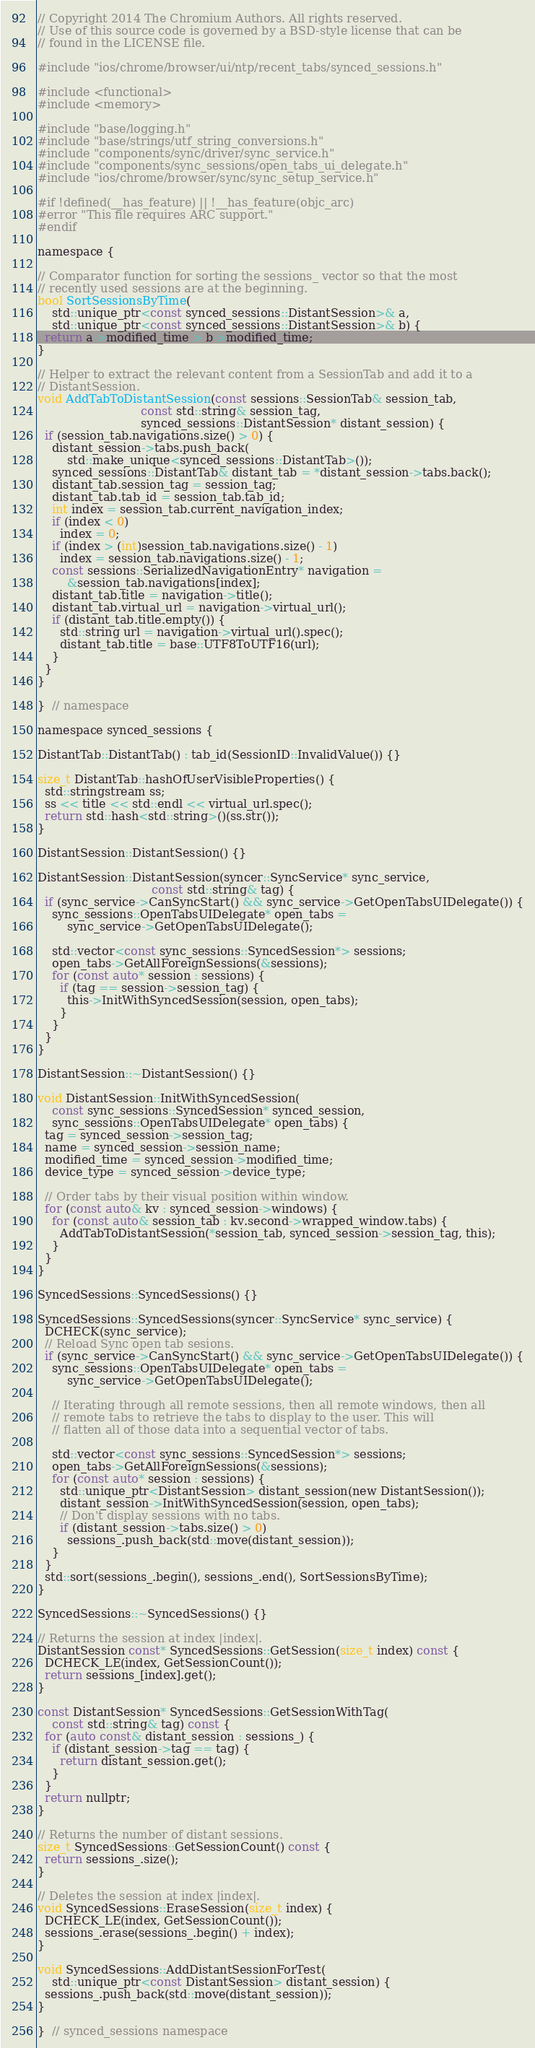<code> <loc_0><loc_0><loc_500><loc_500><_ObjectiveC_>// Copyright 2014 The Chromium Authors. All rights reserved.
// Use of this source code is governed by a BSD-style license that can be
// found in the LICENSE file.

#include "ios/chrome/browser/ui/ntp/recent_tabs/synced_sessions.h"

#include <functional>
#include <memory>

#include "base/logging.h"
#include "base/strings/utf_string_conversions.h"
#include "components/sync/driver/sync_service.h"
#include "components/sync_sessions/open_tabs_ui_delegate.h"
#include "ios/chrome/browser/sync/sync_setup_service.h"

#if !defined(__has_feature) || !__has_feature(objc_arc)
#error "This file requires ARC support."
#endif

namespace {

// Comparator function for sorting the sessions_ vector so that the most
// recently used sessions are at the beginning.
bool SortSessionsByTime(
    std::unique_ptr<const synced_sessions::DistantSession>& a,
    std::unique_ptr<const synced_sessions::DistantSession>& b) {
  return a->modified_time > b->modified_time;
}

// Helper to extract the relevant content from a SessionTab and add it to a
// DistantSession.
void AddTabToDistantSession(const sessions::SessionTab& session_tab,
                            const std::string& session_tag,
                            synced_sessions::DistantSession* distant_session) {
  if (session_tab.navigations.size() > 0) {
    distant_session->tabs.push_back(
        std::make_unique<synced_sessions::DistantTab>());
    synced_sessions::DistantTab& distant_tab = *distant_session->tabs.back();
    distant_tab.session_tag = session_tag;
    distant_tab.tab_id = session_tab.tab_id;
    int index = session_tab.current_navigation_index;
    if (index < 0)
      index = 0;
    if (index > (int)session_tab.navigations.size() - 1)
      index = session_tab.navigations.size() - 1;
    const sessions::SerializedNavigationEntry* navigation =
        &session_tab.navigations[index];
    distant_tab.title = navigation->title();
    distant_tab.virtual_url = navigation->virtual_url();
    if (distant_tab.title.empty()) {
      std::string url = navigation->virtual_url().spec();
      distant_tab.title = base::UTF8ToUTF16(url);
    }
  }
}

}  // namespace

namespace synced_sessions {

DistantTab::DistantTab() : tab_id(SessionID::InvalidValue()) {}

size_t DistantTab::hashOfUserVisibleProperties() {
  std::stringstream ss;
  ss << title << std::endl << virtual_url.spec();
  return std::hash<std::string>()(ss.str());
}

DistantSession::DistantSession() {}

DistantSession::DistantSession(syncer::SyncService* sync_service,
                               const std::string& tag) {
  if (sync_service->CanSyncStart() && sync_service->GetOpenTabsUIDelegate()) {
    sync_sessions::OpenTabsUIDelegate* open_tabs =
        sync_service->GetOpenTabsUIDelegate();

    std::vector<const sync_sessions::SyncedSession*> sessions;
    open_tabs->GetAllForeignSessions(&sessions);
    for (const auto* session : sessions) {
      if (tag == session->session_tag) {
        this->InitWithSyncedSession(session, open_tabs);
      }
    }
  }
}

DistantSession::~DistantSession() {}

void DistantSession::InitWithSyncedSession(
    const sync_sessions::SyncedSession* synced_session,
    sync_sessions::OpenTabsUIDelegate* open_tabs) {
  tag = synced_session->session_tag;
  name = synced_session->session_name;
  modified_time = synced_session->modified_time;
  device_type = synced_session->device_type;

  // Order tabs by their visual position within window.
  for (const auto& kv : synced_session->windows) {
    for (const auto& session_tab : kv.second->wrapped_window.tabs) {
      AddTabToDistantSession(*session_tab, synced_session->session_tag, this);
    }
  }
}

SyncedSessions::SyncedSessions() {}

SyncedSessions::SyncedSessions(syncer::SyncService* sync_service) {
  DCHECK(sync_service);
  // Reload Sync open tab sesions.
  if (sync_service->CanSyncStart() && sync_service->GetOpenTabsUIDelegate()) {
    sync_sessions::OpenTabsUIDelegate* open_tabs =
        sync_service->GetOpenTabsUIDelegate();

    // Iterating through all remote sessions, then all remote windows, then all
    // remote tabs to retrieve the tabs to display to the user. This will
    // flatten all of those data into a sequential vector of tabs.

    std::vector<const sync_sessions::SyncedSession*> sessions;
    open_tabs->GetAllForeignSessions(&sessions);
    for (const auto* session : sessions) {
      std::unique_ptr<DistantSession> distant_session(new DistantSession());
      distant_session->InitWithSyncedSession(session, open_tabs);
      // Don't display sessions with no tabs.
      if (distant_session->tabs.size() > 0)
        sessions_.push_back(std::move(distant_session));
    }
  }
  std::sort(sessions_.begin(), sessions_.end(), SortSessionsByTime);
}

SyncedSessions::~SyncedSessions() {}

// Returns the session at index |index|.
DistantSession const* SyncedSessions::GetSession(size_t index) const {
  DCHECK_LE(index, GetSessionCount());
  return sessions_[index].get();
}

const DistantSession* SyncedSessions::GetSessionWithTag(
    const std::string& tag) const {
  for (auto const& distant_session : sessions_) {
    if (distant_session->tag == tag) {
      return distant_session.get();
    }
  }
  return nullptr;
}

// Returns the number of distant sessions.
size_t SyncedSessions::GetSessionCount() const {
  return sessions_.size();
}

// Deletes the session at index |index|.
void SyncedSessions::EraseSession(size_t index) {
  DCHECK_LE(index, GetSessionCount());
  sessions_.erase(sessions_.begin() + index);
}

void SyncedSessions::AddDistantSessionForTest(
    std::unique_ptr<const DistantSession> distant_session) {
  sessions_.push_back(std::move(distant_session));
}

}  // synced_sessions namespace
</code> 